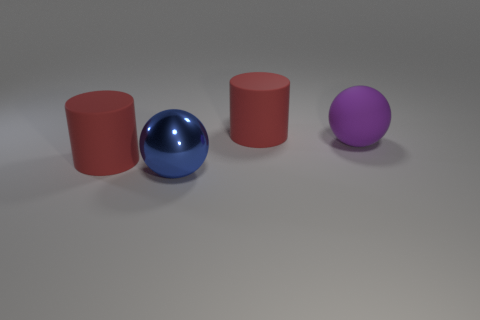Is the purple rubber thing the same shape as the metal object?
Keep it short and to the point. Yes. How many big balls are in front of the purple object and behind the large metallic object?
Offer a very short reply. 0. How many rubber objects are red cylinders or large spheres?
Your answer should be very brief. 3. There is a red cylinder right of the big object left of the metallic thing; how big is it?
Provide a succinct answer. Large. There is a big red cylinder that is left of the red matte cylinder behind the purple matte ball; is there a rubber object on the left side of it?
Provide a short and direct response. No. Are the cylinder that is in front of the purple matte ball and the large sphere that is in front of the purple ball made of the same material?
Your response must be concise. No. How many objects are either big shiny objects or big matte objects that are right of the big blue metallic thing?
Your answer should be compact. 3. What number of big blue things are the same shape as the purple thing?
Provide a succinct answer. 1. There is another ball that is the same size as the metallic sphere; what is its material?
Provide a succinct answer. Rubber. There is a red rubber cylinder in front of the big sphere that is on the right side of the big cylinder to the right of the large blue ball; how big is it?
Give a very brief answer. Large. 